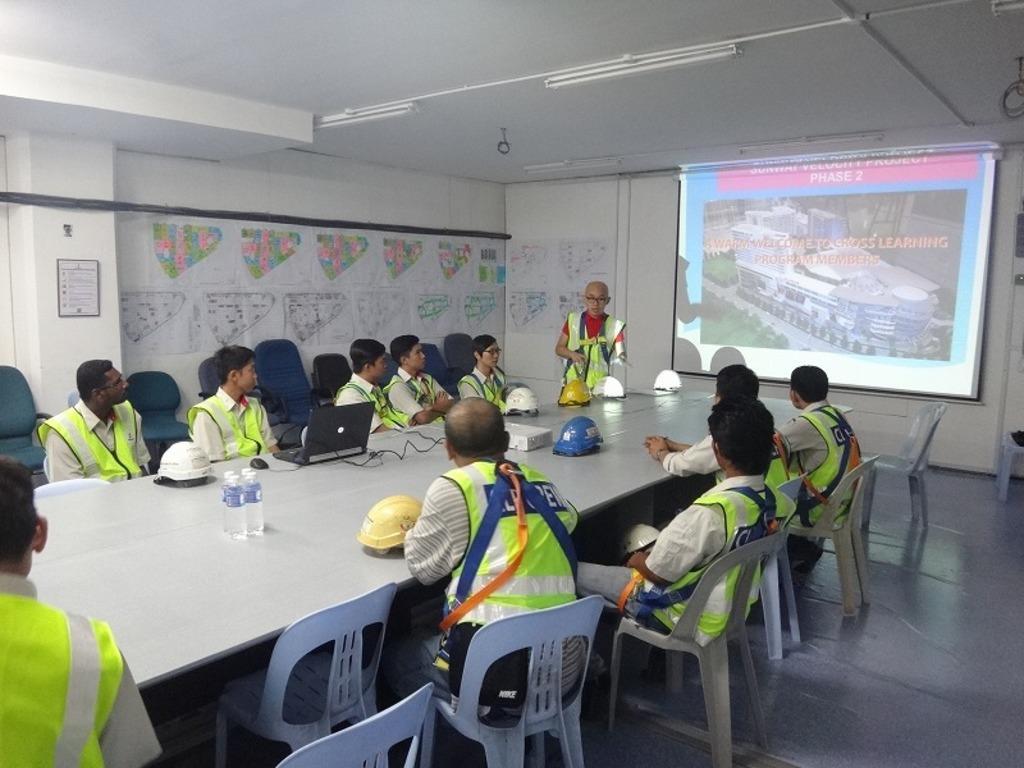Describe this image in one or two sentences. In this picture there are many people sitting on the table. They have a certain uniform. Everyone are looking at the screen. A man is standing and explaining all of them. The roof is in white color. 